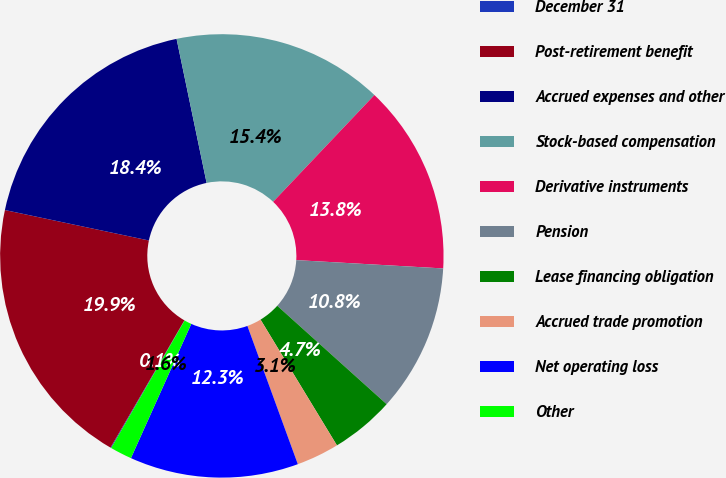<chart> <loc_0><loc_0><loc_500><loc_500><pie_chart><fcel>December 31<fcel>Post-retirement benefit<fcel>Accrued expenses and other<fcel>Stock-based compensation<fcel>Derivative instruments<fcel>Pension<fcel>Lease financing obligation<fcel>Accrued trade promotion<fcel>Net operating loss<fcel>Other<nl><fcel>0.06%<fcel>19.94%<fcel>18.41%<fcel>15.35%<fcel>13.82%<fcel>10.76%<fcel>4.65%<fcel>3.12%<fcel>12.29%<fcel>1.59%<nl></chart> 